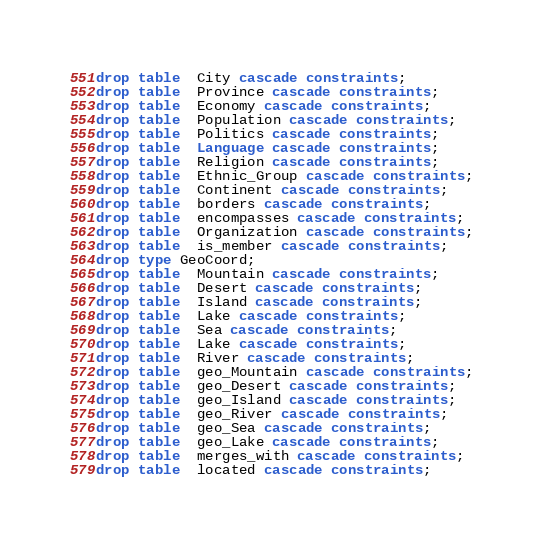Convert code to text. <code><loc_0><loc_0><loc_500><loc_500><_SQL_>drop table  City cascade constraints;
drop table  Province cascade constraints;
drop table  Economy cascade constraints;
drop table  Population cascade constraints;
drop table  Politics cascade constraints;
drop table  Language cascade constraints;
drop table  Religion cascade constraints;
drop table  Ethnic_Group cascade constraints;
drop table  Continent cascade constraints;
drop table  borders cascade constraints;
drop table  encompasses cascade constraints;
drop table  Organization cascade constraints;
drop table  is_member cascade constraints;
drop type GeoCoord;
drop table  Mountain cascade constraints;
drop table  Desert cascade constraints;
drop table  Island cascade constraints;
drop table  Lake cascade constraints;
drop table  Sea cascade constraints;
drop table  Lake cascade constraints;
drop table  River cascade constraints;
drop table  geo_Mountain cascade constraints;
drop table  geo_Desert cascade constraints;
drop table  geo_Island cascade constraints;
drop table  geo_River cascade constraints;
drop table  geo_Sea cascade constraints;
drop table  geo_Lake cascade constraints;
drop table  merges_with cascade constraints;
drop table  located cascade constraints;
</code> 